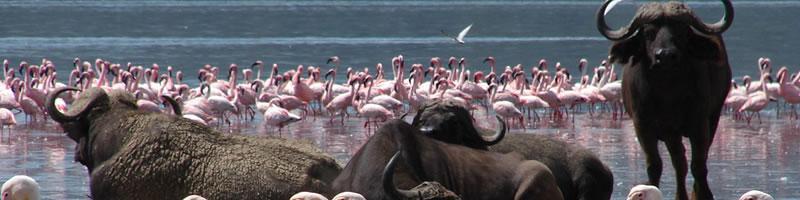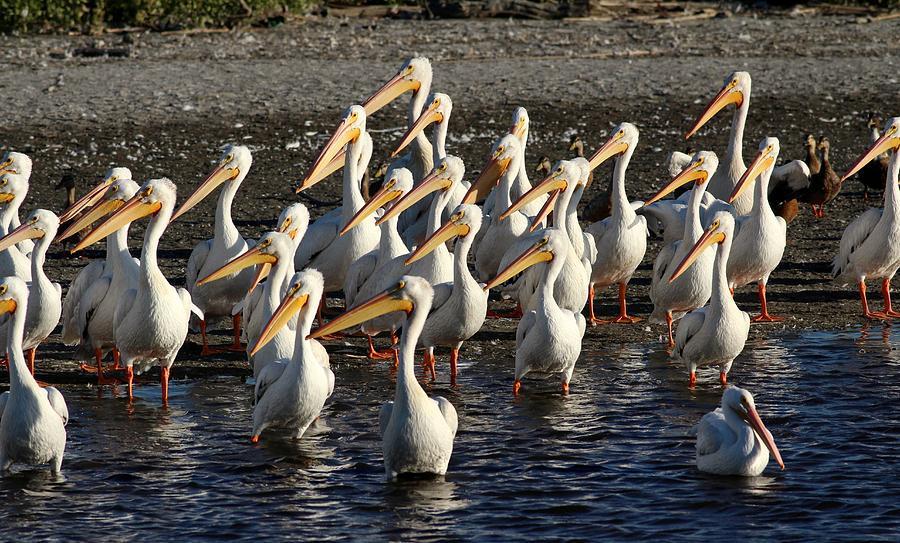The first image is the image on the left, the second image is the image on the right. Assess this claim about the two images: "there are pelicans in the image on the left". Correct or not? Answer yes or no. No. The first image is the image on the left, the second image is the image on the right. For the images displayed, is the sentence "In one image, pink flamingos are amassed in water." factually correct? Answer yes or no. Yes. 